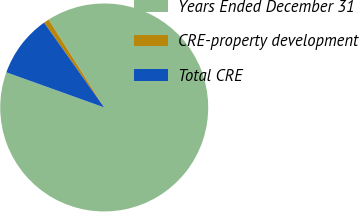Convert chart. <chart><loc_0><loc_0><loc_500><loc_500><pie_chart><fcel>Years Ended December 31<fcel>CRE-property development<fcel>Total CRE<nl><fcel>89.45%<fcel>0.84%<fcel>9.7%<nl></chart> 